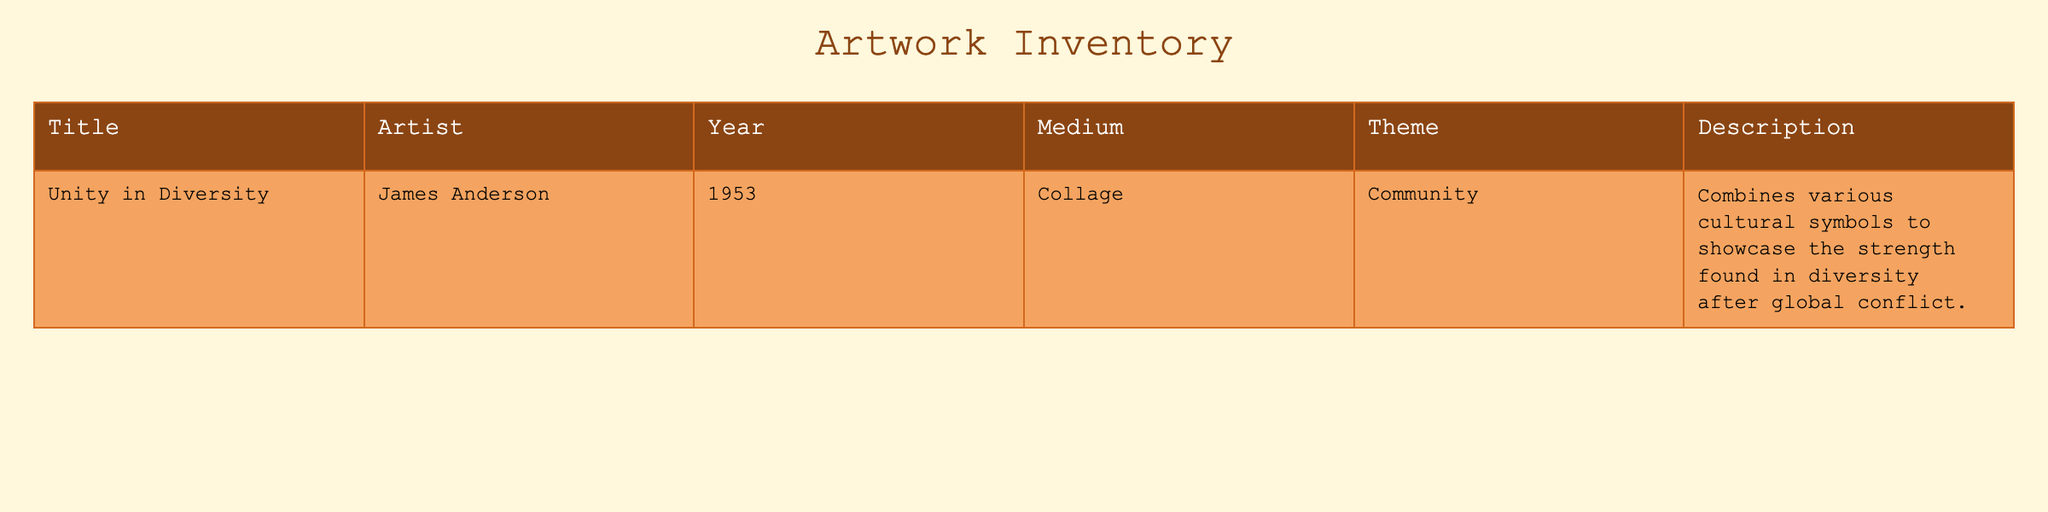What is the title of the artwork created by James Anderson? The table shows the information about various artworks. The value under the "Title" column corresponding to James Anderson is "Unity in Diversity."
Answer: Unity in Diversity What year was "Unity in Diversity" created? Looking at the table, the entry for the artwork by James Anderson indicates that it was created in the year 1953, as seen in the "Year" column.
Answer: 1953 Which medium was used for "Unity in Diversity"? The table specifies that "Unity in Diversity," created by James Anderson, used collage as the medium, indicated in the "Medium" column.
Answer: Collage Is the theme of "Unity in Diversity" related to community? According to the table, the "Theme" column lists community as the theme for the artwork "Unity in Diversity," confirming that it is indeed related to community.
Answer: Yes How many artworks are depicted in the table? The table contains data for a single artwork, which can be verified by counting the number of entries present. There is just one entry listed.
Answer: 1 What is the significance of the symbols used in "Unity in Diversity"? The description in the table states that "Unity in Diversity" combines various cultural symbols to showcase the strength found in diversity after global conflict, illustrating a significant message about community and cooperation.
Answer: Strength in diversity If we categorize themes under community, how many artworks in total would belong to this theme? The table contains only one artwork, "Unity in Diversity," which falls under the theme of community. Hence, based on the data, there is only one artwork within this theme at present.
Answer: 1 Was the artwork "Unity in Diversity" created before or after World War II? Given that World War II ended in 1945 and "Unity in Diversity" was created in 1953, this artwork was created after the war. The year provides a clear indication of it being after the conflict.
Answer: After What can be inferred about the cultural message of "Unity in Diversity"? The artwork's title and description suggest that it conveys a message about embracing diversity and community strength following conflict, indicating a positive outlook on human connections and understanding.
Answer: Embracing diversity 